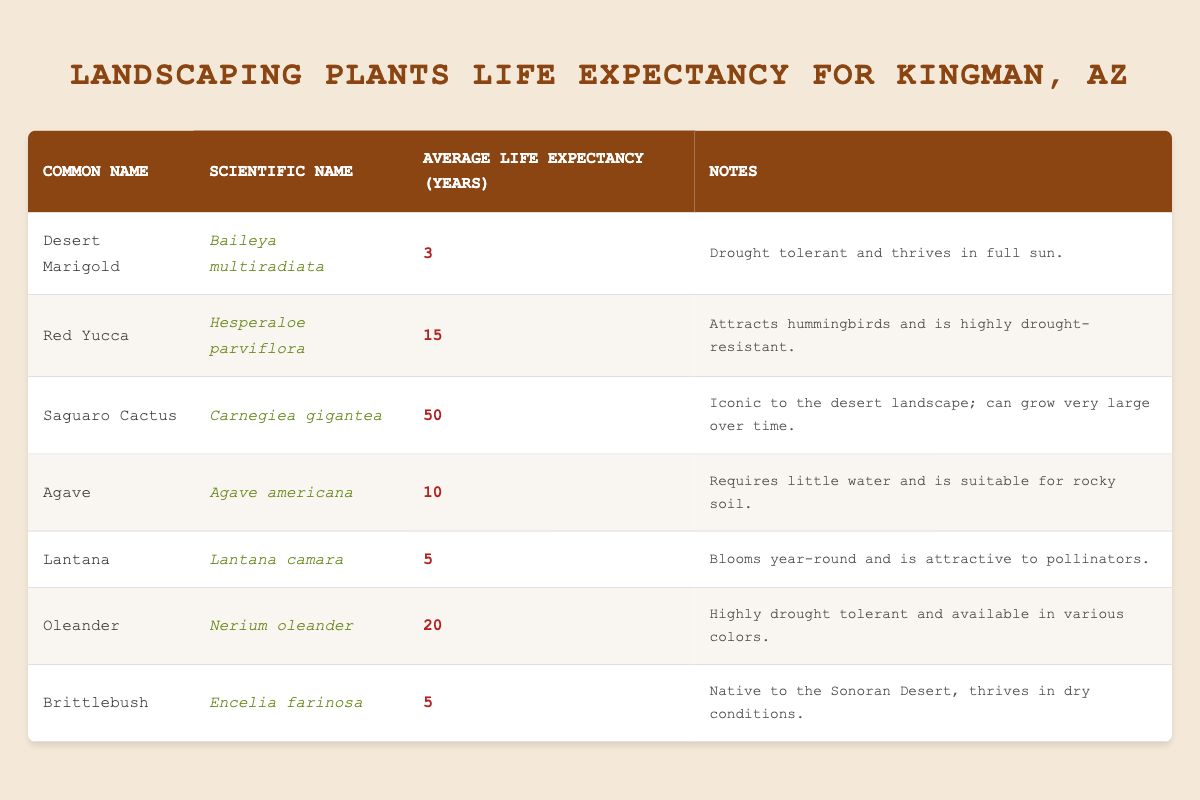What is the average life expectancy of the Saguaro Cactus? The average life expectancy of the Saguaro Cactus is explicitly stated in the table as 50 years.
Answer: 50 Which plant has the longest average life expectancy? The table indicates that the Saguaro Cactus has the longest average life expectancy at 50 years, while the other plants' life expectancies are significantly lower.
Answer: Saguaro Cactus Is Oleander drought tolerant? Yes, the notes in the table confirm that Oleander is highly drought tolerant.
Answer: Yes How much longer does the Red Yucca live compared to the Desert Marigold? The Red Yucca has an average life expectancy of 15 years, and the Desert Marigold has 3 years. The difference in their life expectancies is 15 - 3 = 12 years.
Answer: 12 years What is the average life expectancy of the plants listed in the table? By summing the life expectancies: 3 (Desert Marigold) + 15 (Red Yucca) + 50 (Saguaro Cactus) + 10 (Agave) + 5 (Lantana) + 20 (Oleander) + 5 (Brittlebush) = 108 years. There are 7 plants, so the average is 108 / 7 = 15.43 years.
Answer: 15.43 years Which plants can thrive in dry conditions based on the notes provided? The table mentions that Desert Marigold, Oleander, and Brittlebush all thrive in dry conditions.
Answer: Desert Marigold, Oleander, Brittlebush Does any plant in this list attract pollinators? Yes, the table notes that Lantana is attractive to pollinators, making it evident that it serves that function.
Answer: Yes What is the average life expectancy for the group of plants that are native to the desert? The Saguaro Cactus (50), Brittlebush (5), and Desert Marigold (3) are native to the desert. Their total life expectancy is 50 + 5 + 3 = 58 years, and there are 3 plants, so the average is 58 / 3 = 19.33 years.
Answer: 19.33 years 